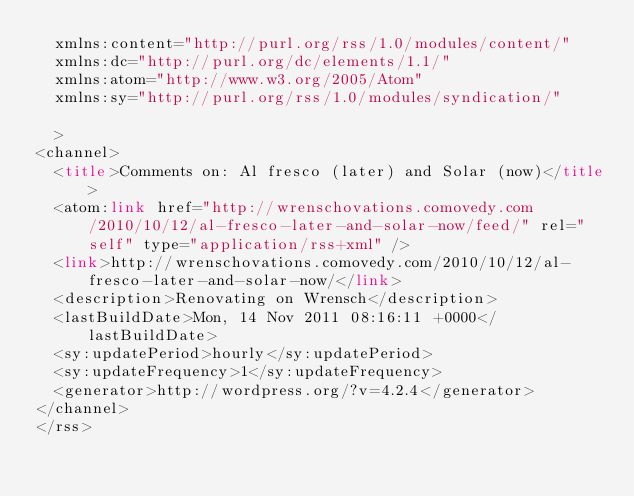Convert code to text. <code><loc_0><loc_0><loc_500><loc_500><_HTML_>	xmlns:content="http://purl.org/rss/1.0/modules/content/"
	xmlns:dc="http://purl.org/dc/elements/1.1/"
	xmlns:atom="http://www.w3.org/2005/Atom"
	xmlns:sy="http://purl.org/rss/1.0/modules/syndication/"
	
	>
<channel>
	<title>Comments on: Al fresco (later) and Solar (now)</title>
	<atom:link href="http://wrenschovations.comovedy.com/2010/10/12/al-fresco-later-and-solar-now/feed/" rel="self" type="application/rss+xml" />
	<link>http://wrenschovations.comovedy.com/2010/10/12/al-fresco-later-and-solar-now/</link>
	<description>Renovating on Wrensch</description>
	<lastBuildDate>Mon, 14 Nov 2011 08:16:11 +0000</lastBuildDate>
	<sy:updatePeriod>hourly</sy:updatePeriod>
	<sy:updateFrequency>1</sy:updateFrequency>
	<generator>http://wordpress.org/?v=4.2.4</generator>
</channel>
</rss>
</code> 